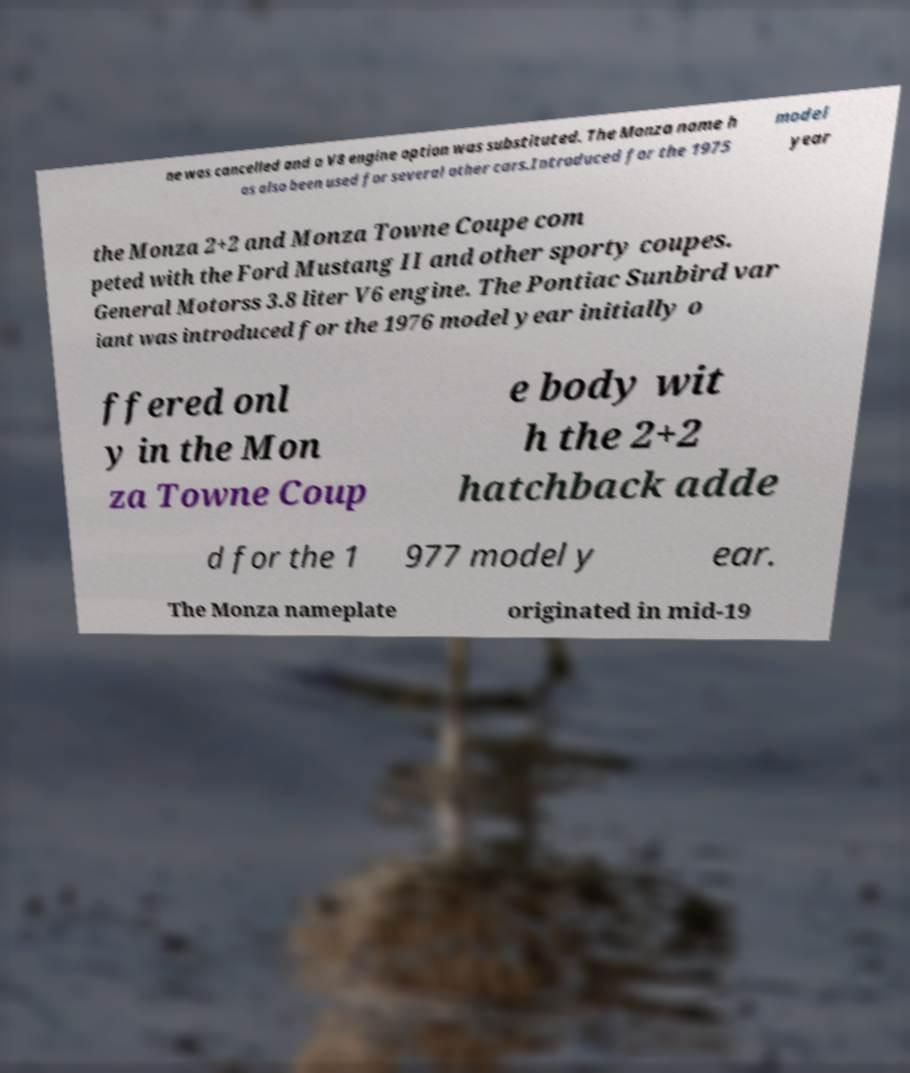Can you read and provide the text displayed in the image?This photo seems to have some interesting text. Can you extract and type it out for me? ne was cancelled and a V8 engine option was substituted. The Monza name h as also been used for several other cars.Introduced for the 1975 model year the Monza 2+2 and Monza Towne Coupe com peted with the Ford Mustang II and other sporty coupes. General Motorss 3.8 liter V6 engine. The Pontiac Sunbird var iant was introduced for the 1976 model year initially o ffered onl y in the Mon za Towne Coup e body wit h the 2+2 hatchback adde d for the 1 977 model y ear. The Monza nameplate originated in mid-19 